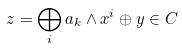<formula> <loc_0><loc_0><loc_500><loc_500>z = \bigoplus _ { i } a _ { k } \wedge x ^ { i } \oplus y \in C</formula> 